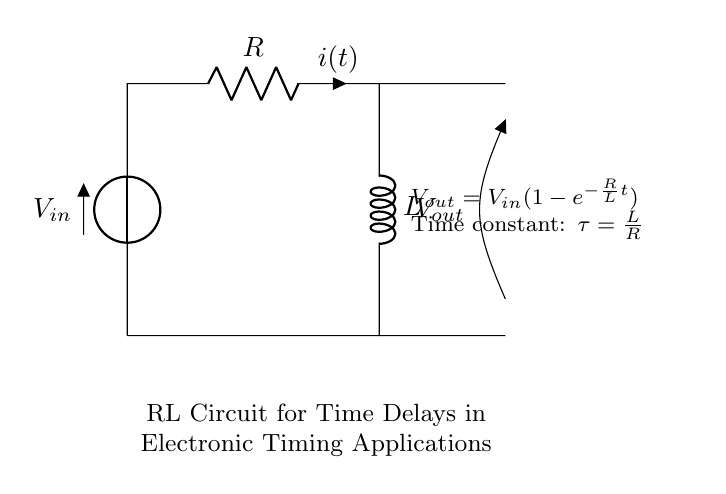What is the input voltage in this circuit? The input voltage is labeled as \( V_{in} \) in the circuit diagram, indicating the voltage source connected at the top.
Answer: \( V_{in} \) What components are present in the circuit? The circuit consists of a resistor \( R \) and an inductor \( L \), which are connected in series, along with a voltage source \( V_{in} \).
Answer: Resistor, Inductor What is the expression for the output voltage? The output voltage is given as \( V_{out} = V_{in}(1-e^{-\frac{R}{L}t}) \), which describes the relationship between the input and output voltages over time in the circuit.
Answer: \( V_{out} = V_{in}(1-e^{-\frac{R}{L}t}) \) What is the time constant of this RL circuit? The time constant \( \tau \) is calculated using the formula \( \tau = \frac{L}{R} \), which indicates how quickly the current rises to its maximum value.
Answer: \( \frac{L}{R} \) Why is the inductor used in this circuit? The inductor is used to create a time delay in the circuit by opposing changes in current, resulting in a gradual increase in output voltage over time.
Answer: To create time delay What happens to the output voltage as time approaches infinity? As time approaches infinity, the term \( e^{-\frac{R}{L}t} \) approaches zero, which means \( V_{out} \) approaches \( V_{in} \) as the steady state is reached.
Answer: Approaches \( V_{in} \) What is the purpose of the resistor in this RL circuit? The resistor limits the current in the circuit and determines the time constant along with the inductor, controlling how quickly the inductor charges.
Answer: To limit current and control time constant 